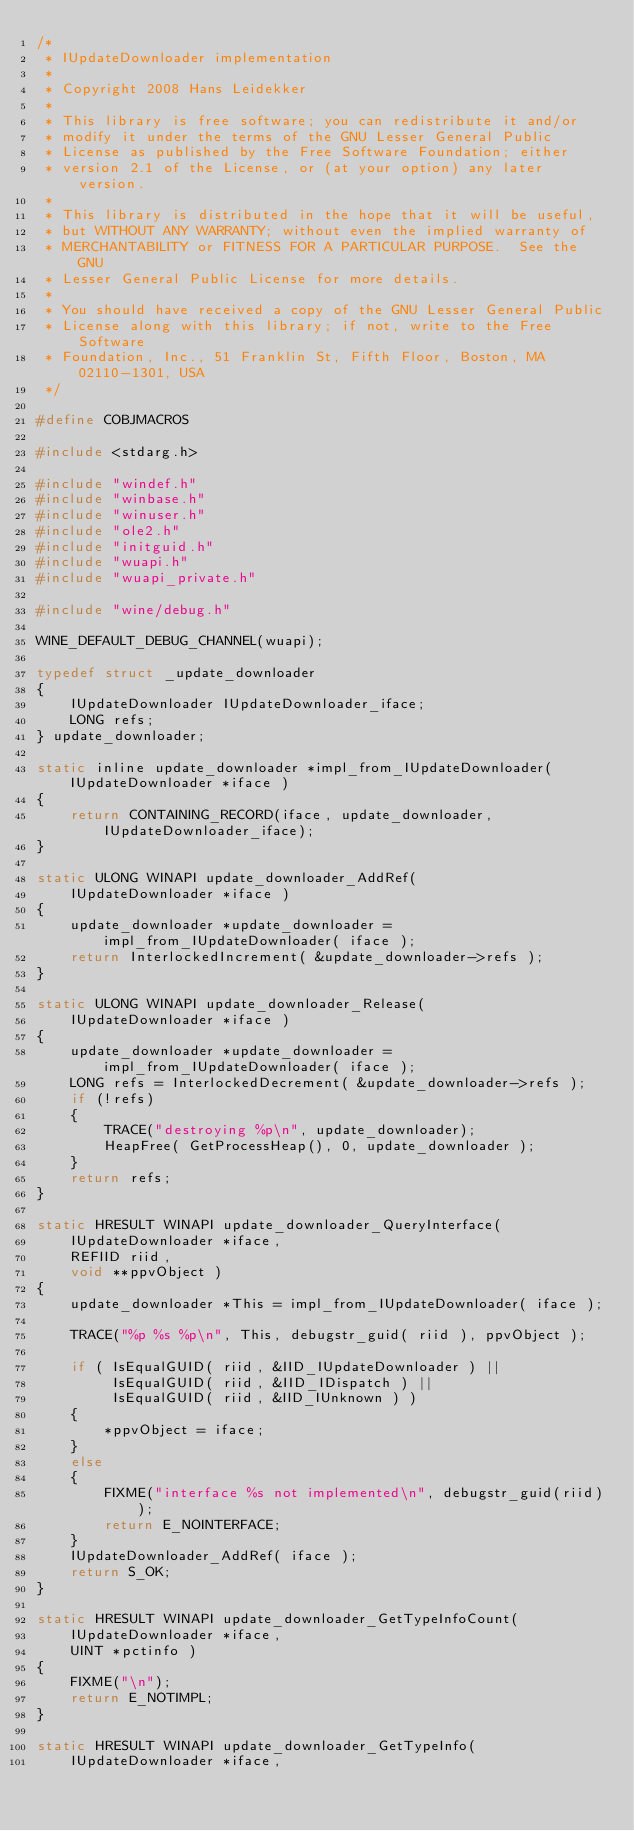<code> <loc_0><loc_0><loc_500><loc_500><_C_>/*
 * IUpdateDownloader implementation
 *
 * Copyright 2008 Hans Leidekker
 *
 * This library is free software; you can redistribute it and/or
 * modify it under the terms of the GNU Lesser General Public
 * License as published by the Free Software Foundation; either
 * version 2.1 of the License, or (at your option) any later version.
 *
 * This library is distributed in the hope that it will be useful,
 * but WITHOUT ANY WARRANTY; without even the implied warranty of
 * MERCHANTABILITY or FITNESS FOR A PARTICULAR PURPOSE.  See the GNU
 * Lesser General Public License for more details.
 *
 * You should have received a copy of the GNU Lesser General Public
 * License along with this library; if not, write to the Free Software
 * Foundation, Inc., 51 Franklin St, Fifth Floor, Boston, MA 02110-1301, USA
 */

#define COBJMACROS

#include <stdarg.h>

#include "windef.h"
#include "winbase.h"
#include "winuser.h"
#include "ole2.h"
#include "initguid.h"
#include "wuapi.h"
#include "wuapi_private.h"

#include "wine/debug.h"

WINE_DEFAULT_DEBUG_CHANNEL(wuapi);

typedef struct _update_downloader
{
    IUpdateDownloader IUpdateDownloader_iface;
    LONG refs;
} update_downloader;

static inline update_downloader *impl_from_IUpdateDownloader( IUpdateDownloader *iface )
{
    return CONTAINING_RECORD(iface, update_downloader, IUpdateDownloader_iface);
}

static ULONG WINAPI update_downloader_AddRef(
    IUpdateDownloader *iface )
{
    update_downloader *update_downloader = impl_from_IUpdateDownloader( iface );
    return InterlockedIncrement( &update_downloader->refs );
}

static ULONG WINAPI update_downloader_Release(
    IUpdateDownloader *iface )
{
    update_downloader *update_downloader = impl_from_IUpdateDownloader( iface );
    LONG refs = InterlockedDecrement( &update_downloader->refs );
    if (!refs)
    {
        TRACE("destroying %p\n", update_downloader);
        HeapFree( GetProcessHeap(), 0, update_downloader );
    }
    return refs;
}

static HRESULT WINAPI update_downloader_QueryInterface(
    IUpdateDownloader *iface,
    REFIID riid,
    void **ppvObject )
{
    update_downloader *This = impl_from_IUpdateDownloader( iface );

    TRACE("%p %s %p\n", This, debugstr_guid( riid ), ppvObject );

    if ( IsEqualGUID( riid, &IID_IUpdateDownloader ) ||
         IsEqualGUID( riid, &IID_IDispatch ) ||
         IsEqualGUID( riid, &IID_IUnknown ) )
    {
        *ppvObject = iface;
    }
    else
    {
        FIXME("interface %s not implemented\n", debugstr_guid(riid));
        return E_NOINTERFACE;
    }
    IUpdateDownloader_AddRef( iface );
    return S_OK;
}

static HRESULT WINAPI update_downloader_GetTypeInfoCount(
    IUpdateDownloader *iface,
    UINT *pctinfo )
{
    FIXME("\n");
    return E_NOTIMPL;
}

static HRESULT WINAPI update_downloader_GetTypeInfo(
    IUpdateDownloader *iface,</code> 